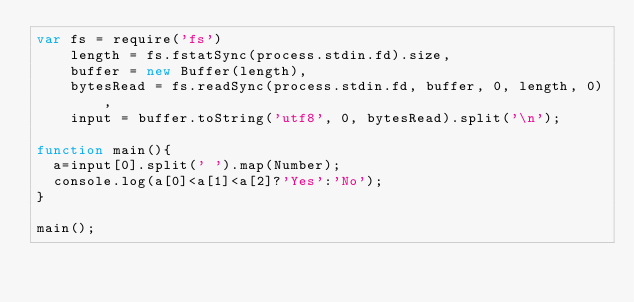Convert code to text. <code><loc_0><loc_0><loc_500><loc_500><_JavaScript_>var fs = require('fs')
    length = fs.fstatSync(process.stdin.fd).size,
    buffer = new Buffer(length),
    bytesRead = fs.readSync(process.stdin.fd, buffer, 0, length, 0),
    input = buffer.toString('utf8', 0, bytesRead).split('\n');

function main(){
	a=input[0].split(' ').map(Number);
	console.log(a[0]<a[1]<a[2]?'Yes':'No');
}

main();
</code> 